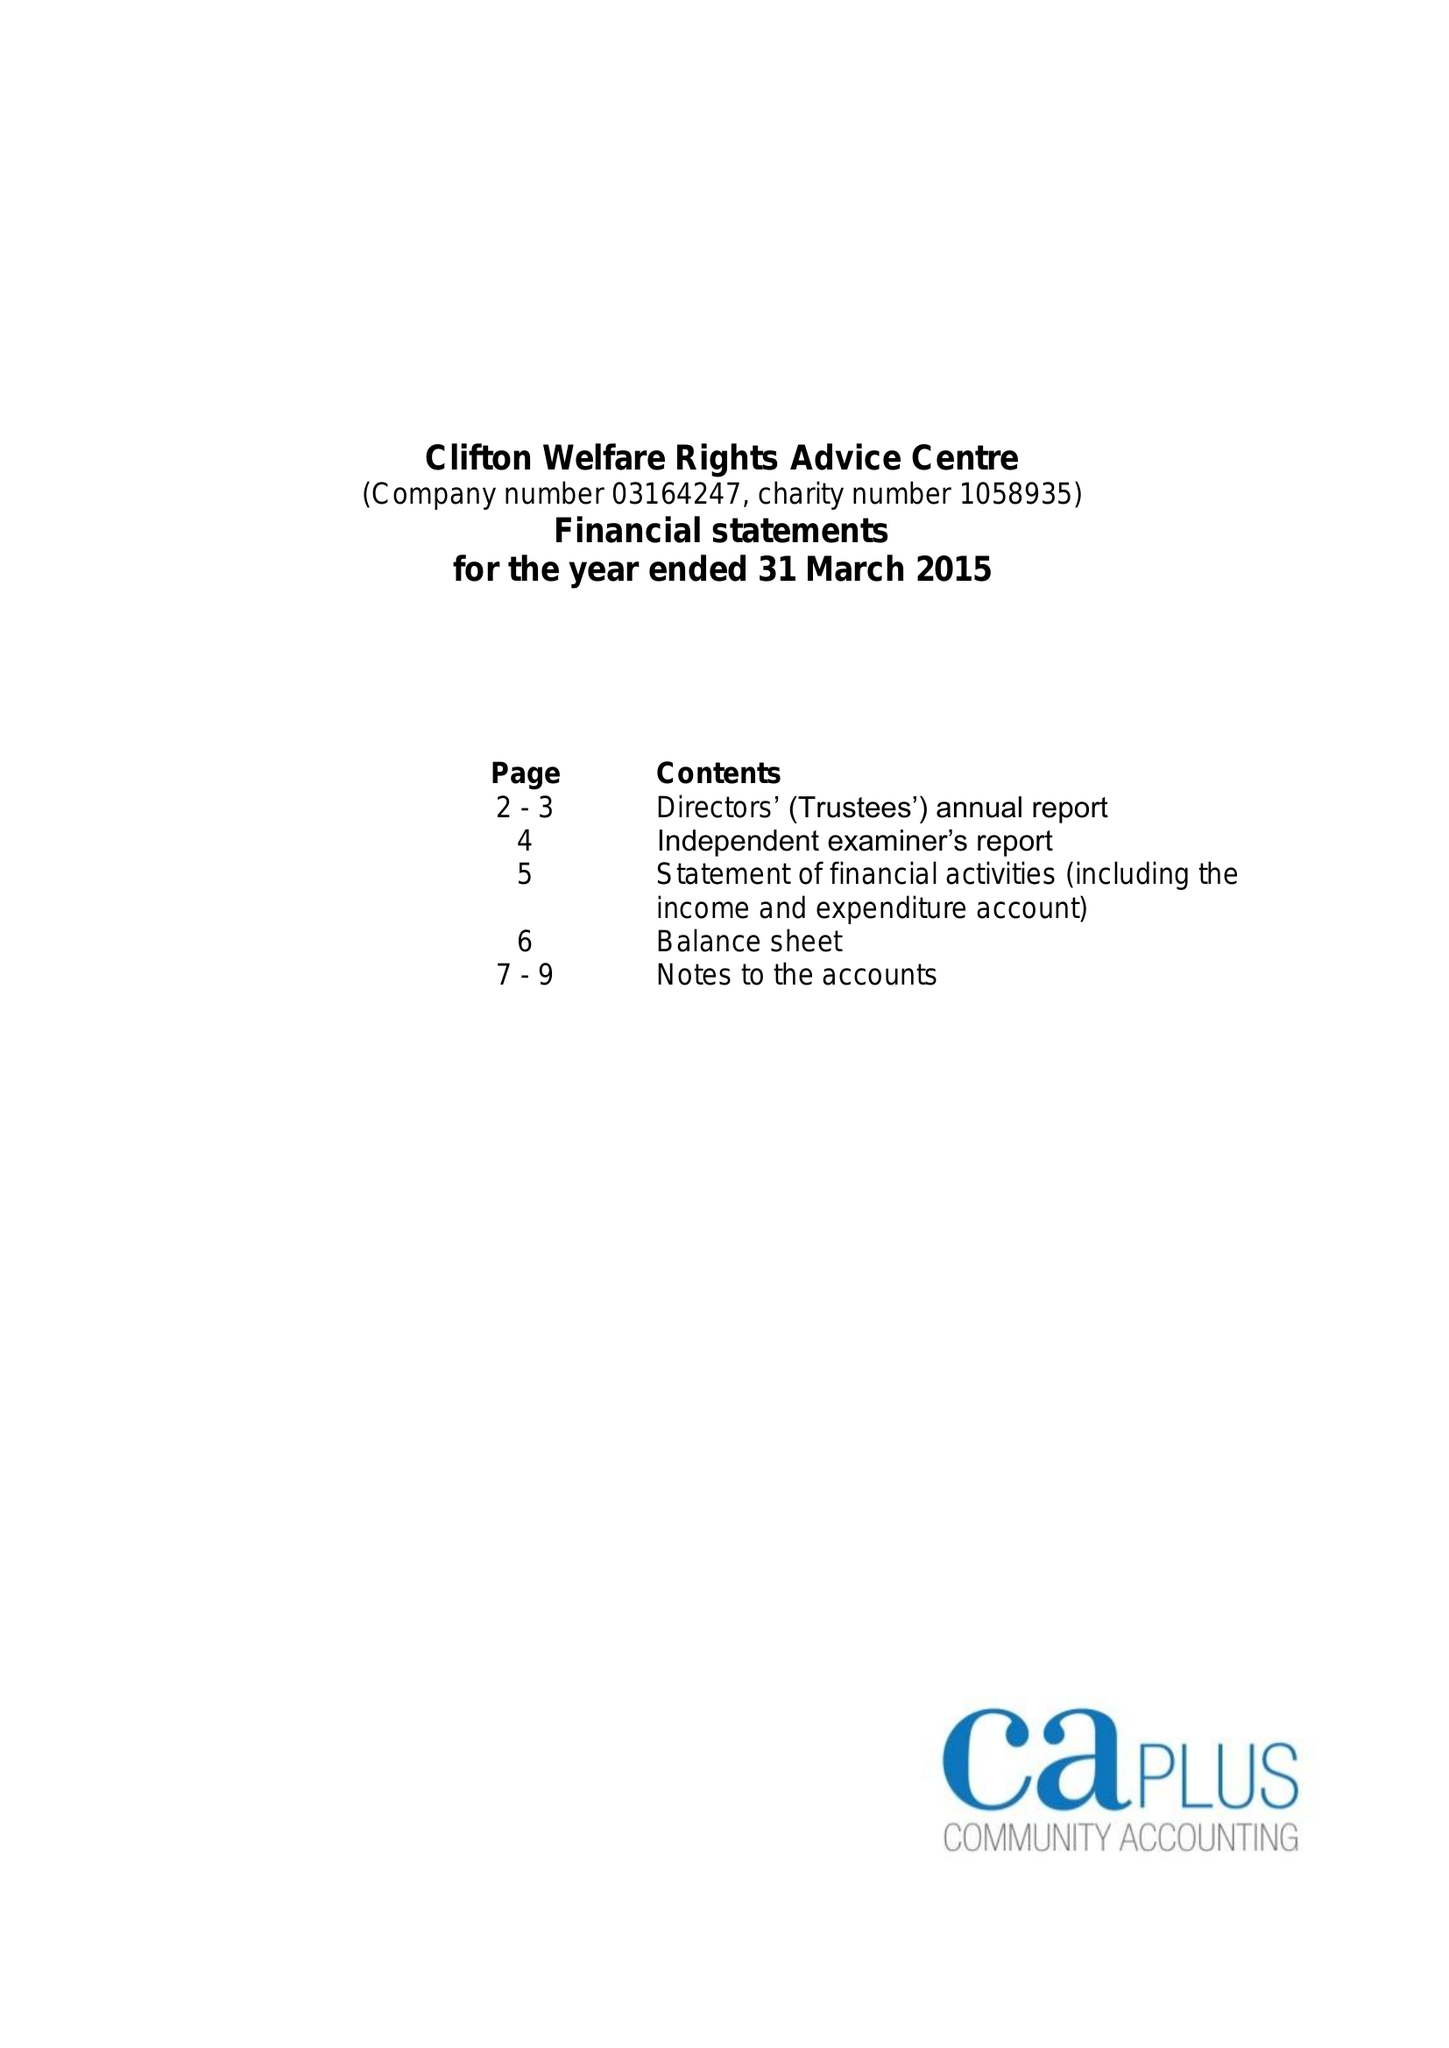What is the value for the report_date?
Answer the question using a single word or phrase. 2015-03-31 